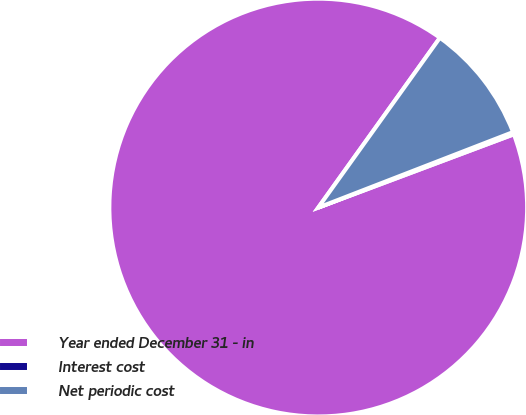<chart> <loc_0><loc_0><loc_500><loc_500><pie_chart><fcel>Year ended December 31 - in<fcel>Interest cost<fcel>Net periodic cost<nl><fcel>90.6%<fcel>0.18%<fcel>9.22%<nl></chart> 